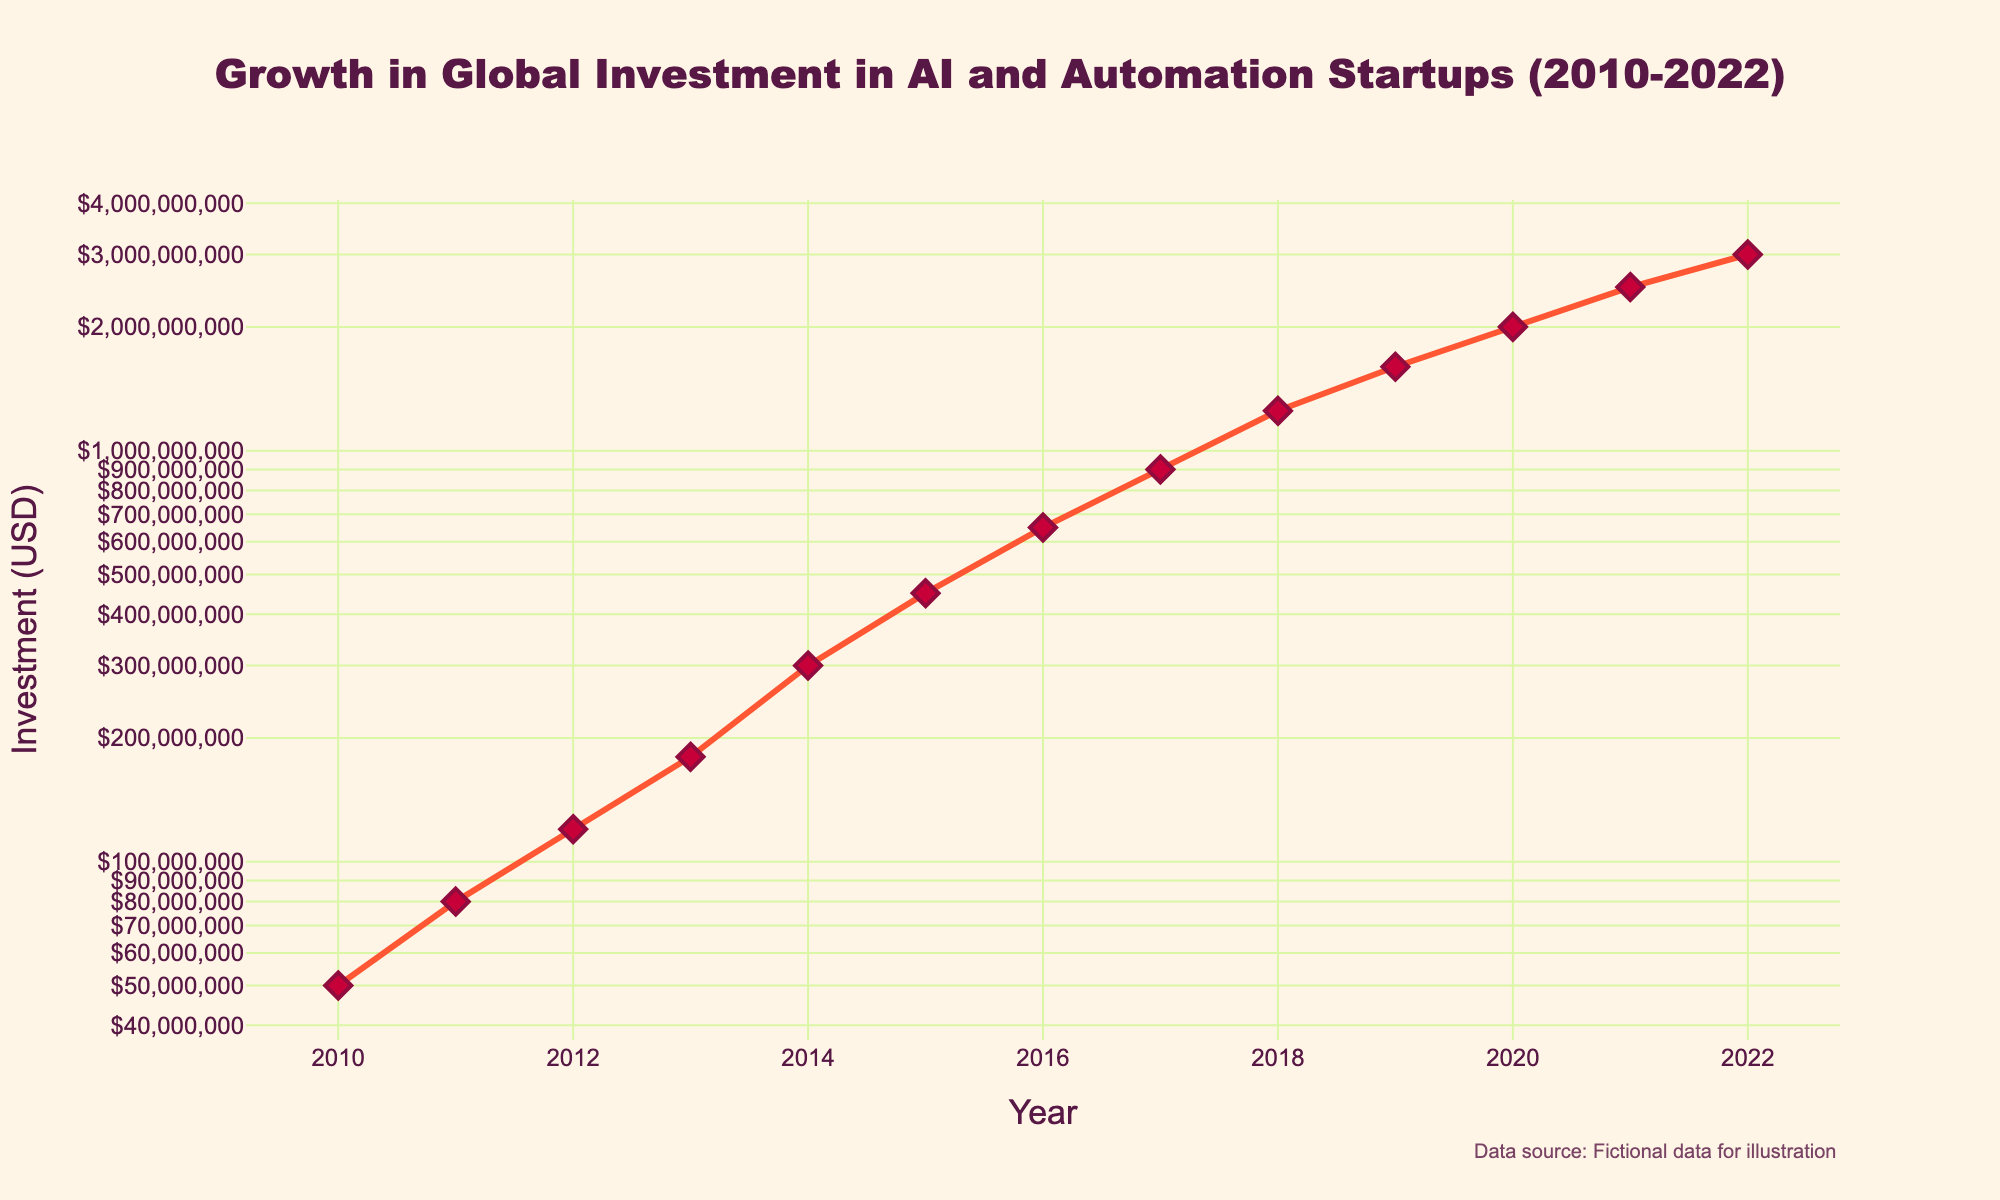What is the title of the plot? The title is located at the top of the plot, centered, and reads as follows: 'Growth in Global Investment in AI and Automation Startups (2010-2022)'
Answer: Growth in Global Investment in AI and Automation Startups (2010-2022) How many years does the plot cover? The x-axis spans from 2010 to 2022. The data points for each year between 2010 and 2022 indicate the number of years covered.
Answer: 13 years In what year was the investment around $1.25 billion? By looking at the y-axis (log scale) and identifying the data point close to $1.25 billion, we can locate the corresponding year on the x-axis.
Answer: 2018 What is the trend in global investment in AI and Automation Startups from 2010 to 2022? Observe the overall direction of the markers and lines from left to right. The investment values increase consistently over the years.
Answer: Increasing trend Which year experienced the highest investment growth compared to the previous year? Calculate the difference in investment between consecutive years and identify the year with the largest increase. The jump from $1.6 billion in 2019 to $2 billion in 2020 is the largest jump.
Answer: 2020 How much more was invested in AI and Automation Startups in 2022 than in 2010? Calculate the difference between the investment values in 2022 and 2010. 3,000,000,000 - 50,000,000 = 2,950,000,000.
Answer: $2.95 billion How does the growth rate between 2010-2012 compare to 2020-2022? Calculate differences and growth rates for both intervals: 
2010-2012: (120,000,000-50,000,000)/50,000,000 
= 1.4 (140%)
2020-2022: (3,000,000,000-2,000,000,000)/2,000,000,000 
= 0.5 (50%)
Answer: The growth rate was higher in 2010-2012 What was the average annual investment during the 2010-2022 period? Sum the total investment for all years and divide by the number of years: 
(50,000,000 + 80,000,000 + 120,000,000 + 180,000,000 + 300,000,000 + 450,000,000 + 650,000,000 + 900,000,000 + 1,250,000,000 + 1,600,000,000 + 2,000,000,000 + 2,500,000,000 + 3,000,000,000) / 13 
= 12,080,000,000 / 13
Answer: $929.2 million Between which consecutive years did the investment see the smallest increase? Determine the differences between each pair of consecutive years, and identify the smallest difference:
2010 to 2011: 30M, 2011 to 2012: 40M, …, 2021 to 2022: 500M. The smallest increase is from 2012 to 2013 ($60 million).
Answer: 2012-2013 